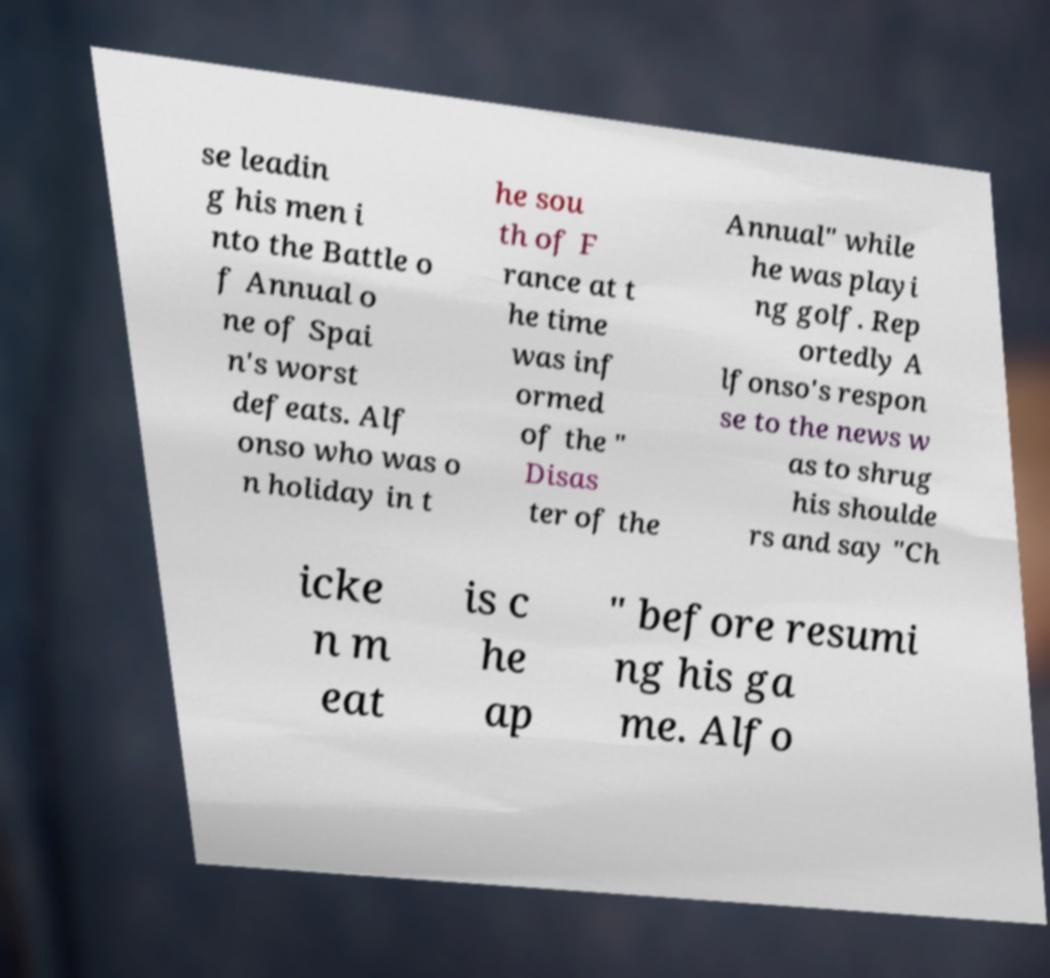Please read and relay the text visible in this image. What does it say? se leadin g his men i nto the Battle o f Annual o ne of Spai n's worst defeats. Alf onso who was o n holiday in t he sou th of F rance at t he time was inf ormed of the " Disas ter of the Annual" while he was playi ng golf. Rep ortedly A lfonso's respon se to the news w as to shrug his shoulde rs and say "Ch icke n m eat is c he ap " before resumi ng his ga me. Alfo 